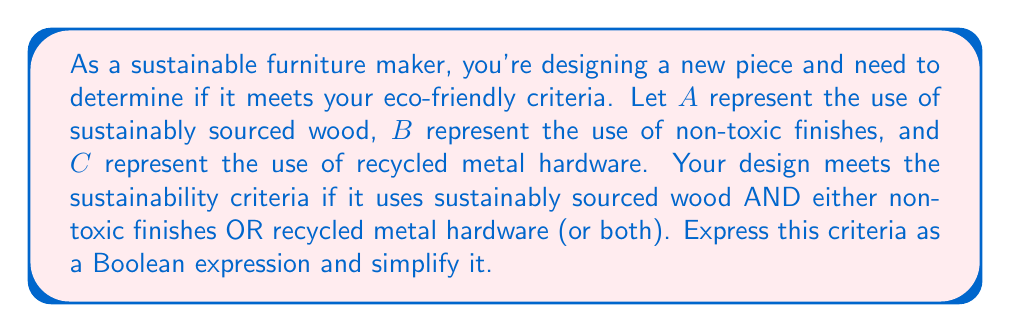Show me your answer to this math problem. Let's approach this step-by-step:

1) First, we need to translate the criteria into a Boolean expression:
   - Must use sustainably sourced wood (A)
   - AND
   - Must use either non-toxic finishes (B) OR recycled metal hardware (C) (or both)

2) This can be written as:
   $$ A \land (B \lor C) $$

3) This expression is already in its simplest form. Let's break it down:
   - $A \land$ ensures that sustainably sourced wood is always used
   - $(B \lor C)$ allows for either non-toxic finishes, recycled metal hardware, or both

4) We can verify this is the simplest form by applying the distributive law:
   $$ A \land (B \lor C) = (A \land B) \lor (A \land C) $$

5) However, this expanded form is not simpler, as it uses more operations and repeats $A$.

Therefore, the original expression $A \land (B \lor C)$ is the simplest form that accurately represents the sustainability criteria.
Answer: $A \land (B \lor C)$ 